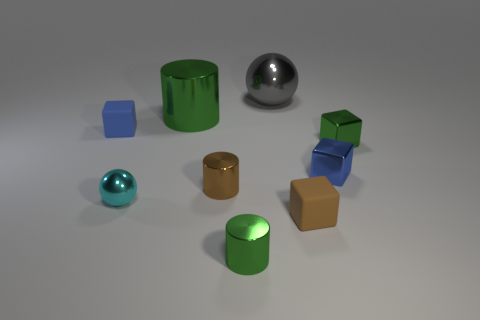How many other shiny cylinders have the same color as the big shiny cylinder?
Offer a very short reply. 1. Is there anything else that has the same shape as the big gray object?
Provide a short and direct response. Yes. What color is the other rubber object that is the same shape as the small blue rubber object?
Give a very brief answer. Brown. There is a tiny brown matte thing; is it the same shape as the object that is left of the cyan metal sphere?
Keep it short and to the point. Yes. How many objects are matte cubes to the left of the brown cube or cylinders that are behind the small blue rubber cube?
Provide a short and direct response. 2. What is the tiny brown cube made of?
Your answer should be very brief. Rubber. How many other objects are there of the same size as the brown cylinder?
Keep it short and to the point. 6. What size is the blue rubber cube behind the small brown rubber cube?
Keep it short and to the point. Small. What material is the tiny brown cylinder behind the tiny green object to the left of the small blue block right of the tiny cyan ball made of?
Your answer should be compact. Metal. Do the small brown rubber thing and the gray shiny thing have the same shape?
Make the answer very short. No. 